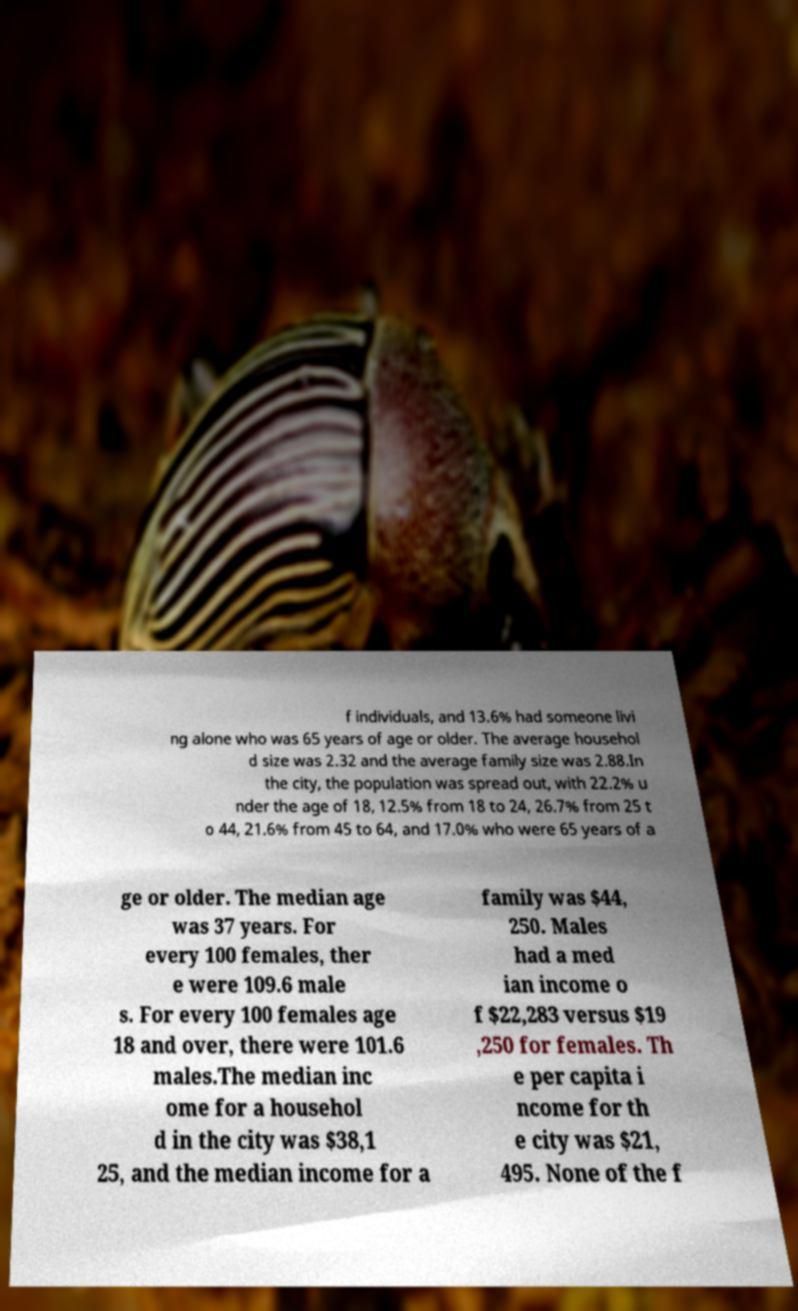Could you extract and type out the text from this image? f individuals, and 13.6% had someone livi ng alone who was 65 years of age or older. The average househol d size was 2.32 and the average family size was 2.88.In the city, the population was spread out, with 22.2% u nder the age of 18, 12.5% from 18 to 24, 26.7% from 25 t o 44, 21.6% from 45 to 64, and 17.0% who were 65 years of a ge or older. The median age was 37 years. For every 100 females, ther e were 109.6 male s. For every 100 females age 18 and over, there were 101.6 males.The median inc ome for a househol d in the city was $38,1 25, and the median income for a family was $44, 250. Males had a med ian income o f $22,283 versus $19 ,250 for females. Th e per capita i ncome for th e city was $21, 495. None of the f 